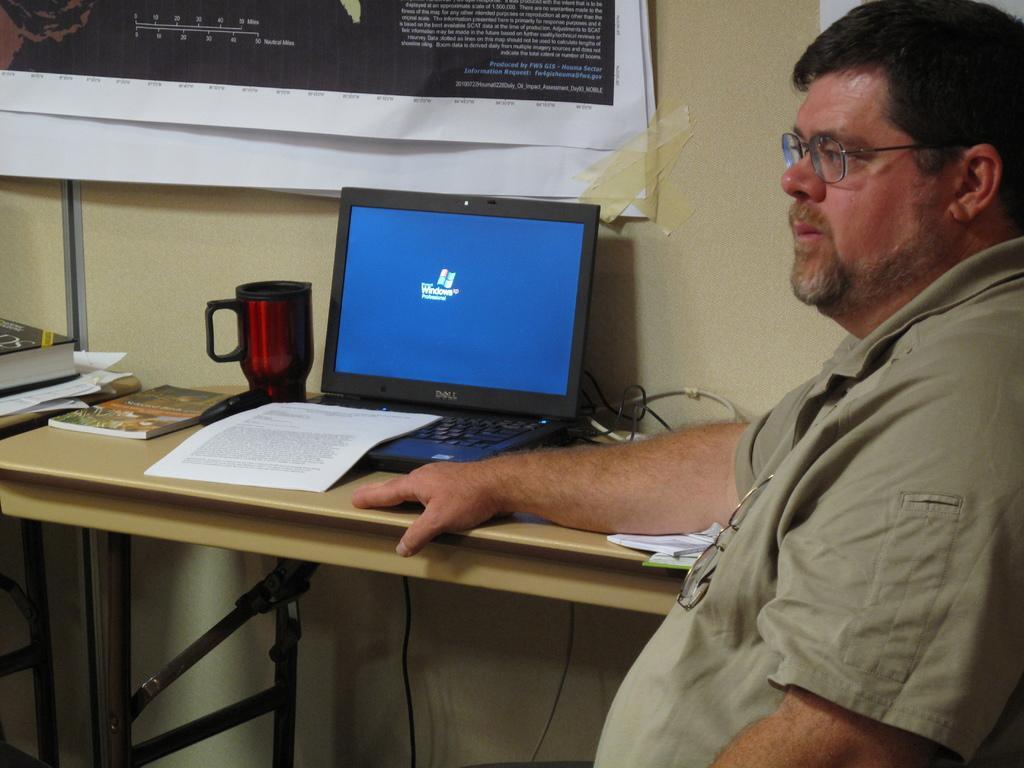Describe this image in one or two sentences. In this picture we can see man sitting and beside to him there is table and on table we can see paper, cup, laptop, books and in background we can see posters to wall. 